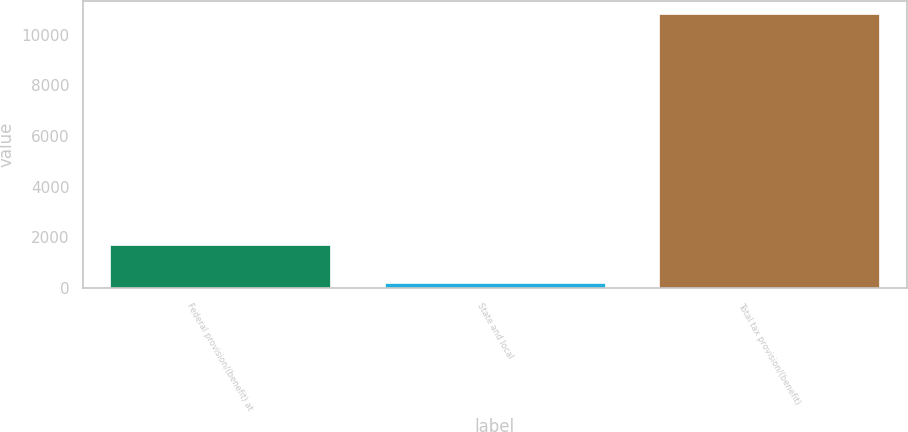Convert chart. <chart><loc_0><loc_0><loc_500><loc_500><bar_chart><fcel>Federal provision/(benefit) at<fcel>State and local<fcel>Total tax provision/(benefit)<nl><fcel>1697<fcel>205<fcel>10799<nl></chart> 